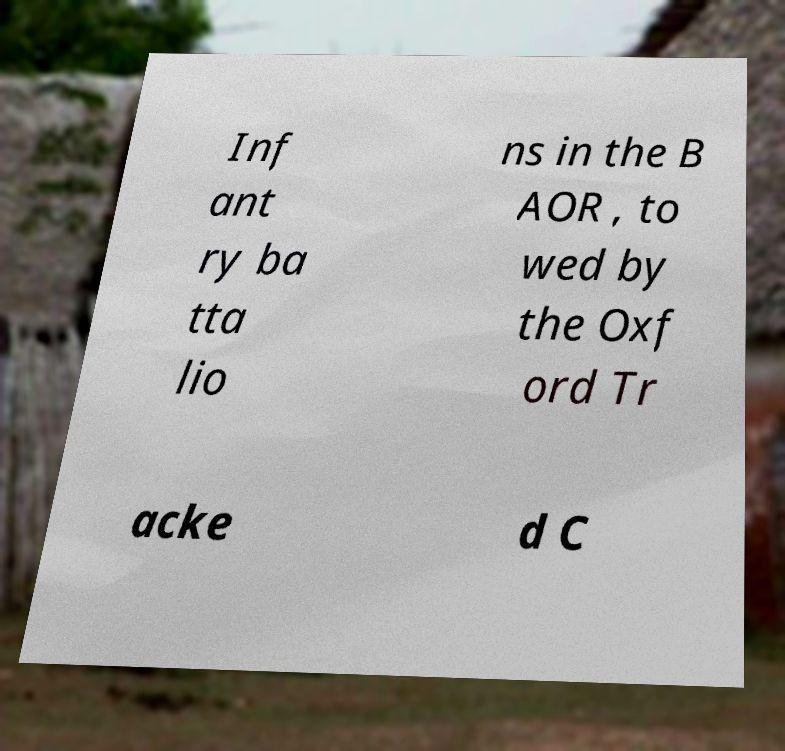Could you extract and type out the text from this image? Inf ant ry ba tta lio ns in the B AOR , to wed by the Oxf ord Tr acke d C 